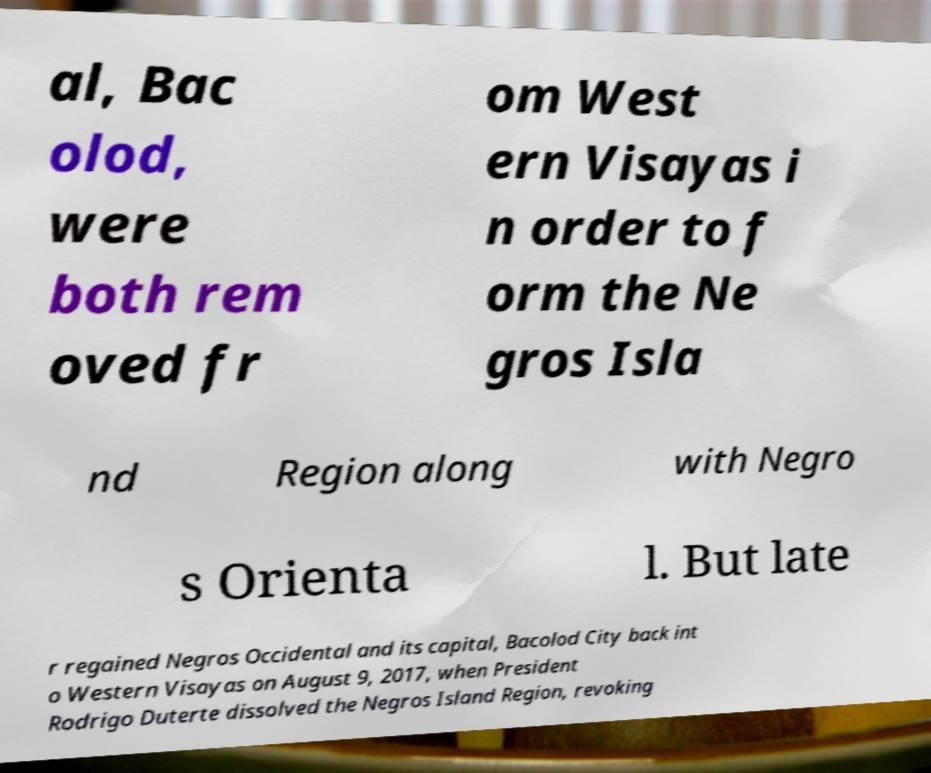There's text embedded in this image that I need extracted. Can you transcribe it verbatim? al, Bac olod, were both rem oved fr om West ern Visayas i n order to f orm the Ne gros Isla nd Region along with Negro s Orienta l. But late r regained Negros Occidental and its capital, Bacolod City back int o Western Visayas on August 9, 2017, when President Rodrigo Duterte dissolved the Negros Island Region, revoking 